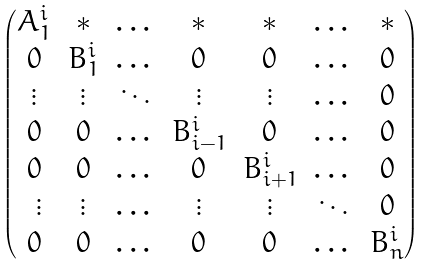<formula> <loc_0><loc_0><loc_500><loc_500>\begin{pmatrix} A _ { 1 } ^ { i } & * & \dots & * & * & \dots & * \\ 0 & B _ { 1 } ^ { i } & \dots & 0 & 0 & \dots & 0 \\ \vdots & \vdots & \ddots & \vdots & \vdots & \dots & 0 \\ 0 & 0 & \dots & B ^ { i } _ { i - 1 } & 0 & \dots & 0 \\ 0 & 0 & \dots & 0 & B ^ { i } _ { i + 1 } & \dots & 0 \\ \ \vdots & \vdots & \dots & \vdots & \vdots & \ddots & 0 \\ 0 & 0 & \dots & 0 & 0 & \dots & B _ { n } ^ { i } \end{pmatrix}</formula> 